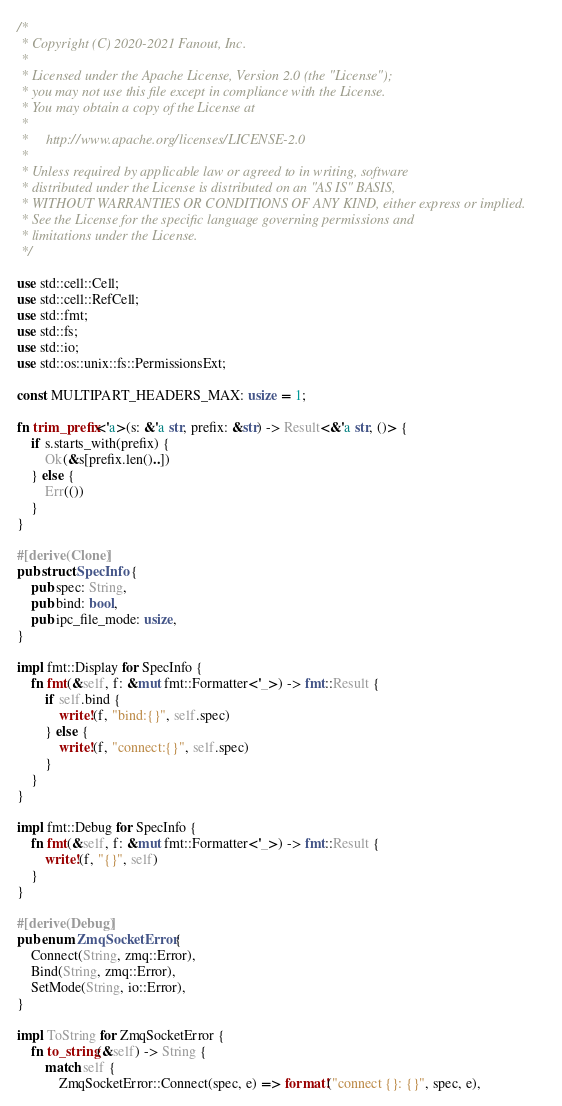Convert code to text. <code><loc_0><loc_0><loc_500><loc_500><_Rust_>/*
 * Copyright (C) 2020-2021 Fanout, Inc.
 *
 * Licensed under the Apache License, Version 2.0 (the "License");
 * you may not use this file except in compliance with the License.
 * You may obtain a copy of the License at
 *
 *     http://www.apache.org/licenses/LICENSE-2.0
 *
 * Unless required by applicable law or agreed to in writing, software
 * distributed under the License is distributed on an "AS IS" BASIS,
 * WITHOUT WARRANTIES OR CONDITIONS OF ANY KIND, either express or implied.
 * See the License for the specific language governing permissions and
 * limitations under the License.
 */

use std::cell::Cell;
use std::cell::RefCell;
use std::fmt;
use std::fs;
use std::io;
use std::os::unix::fs::PermissionsExt;

const MULTIPART_HEADERS_MAX: usize = 1;

fn trim_prefix<'a>(s: &'a str, prefix: &str) -> Result<&'a str, ()> {
    if s.starts_with(prefix) {
        Ok(&s[prefix.len()..])
    } else {
        Err(())
    }
}

#[derive(Clone)]
pub struct SpecInfo {
    pub spec: String,
    pub bind: bool,
    pub ipc_file_mode: usize,
}

impl fmt::Display for SpecInfo {
    fn fmt(&self, f: &mut fmt::Formatter<'_>) -> fmt::Result {
        if self.bind {
            write!(f, "bind:{}", self.spec)
        } else {
            write!(f, "connect:{}", self.spec)
        }
    }
}

impl fmt::Debug for SpecInfo {
    fn fmt(&self, f: &mut fmt::Formatter<'_>) -> fmt::Result {
        write!(f, "{}", self)
    }
}

#[derive(Debug)]
pub enum ZmqSocketError {
    Connect(String, zmq::Error),
    Bind(String, zmq::Error),
    SetMode(String, io::Error),
}

impl ToString for ZmqSocketError {
    fn to_string(&self) -> String {
        match self {
            ZmqSocketError::Connect(spec, e) => format!("connect {}: {}", spec, e),</code> 